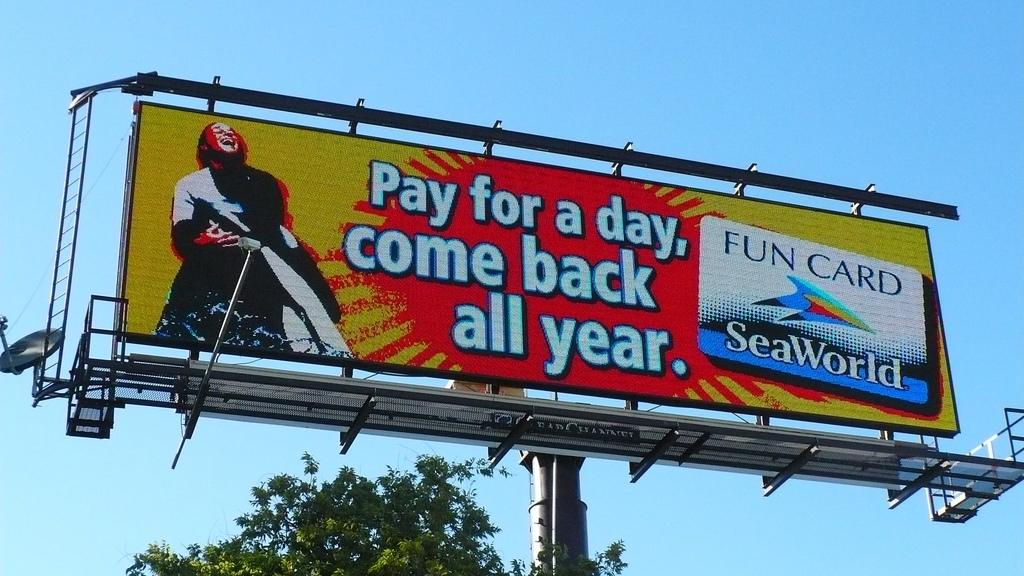<image>
Relay a brief, clear account of the picture shown. SeaWorld is advertised on a billboard that includes an offer to pay for a day and get the year covered. 